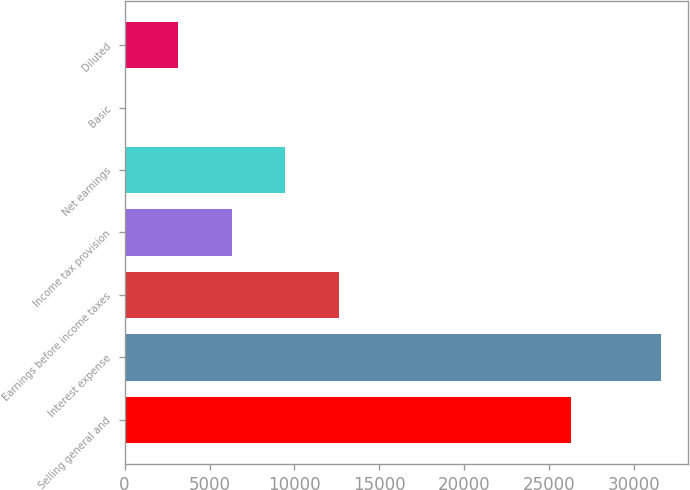Convert chart. <chart><loc_0><loc_0><loc_500><loc_500><bar_chart><fcel>Selling general and<fcel>Interest expense<fcel>Earnings before income taxes<fcel>Income tax provision<fcel>Net earnings<fcel>Basic<fcel>Diluted<nl><fcel>26286<fcel>31570<fcel>12628<fcel>6314.02<fcel>9471.02<fcel>0.02<fcel>3157.02<nl></chart> 